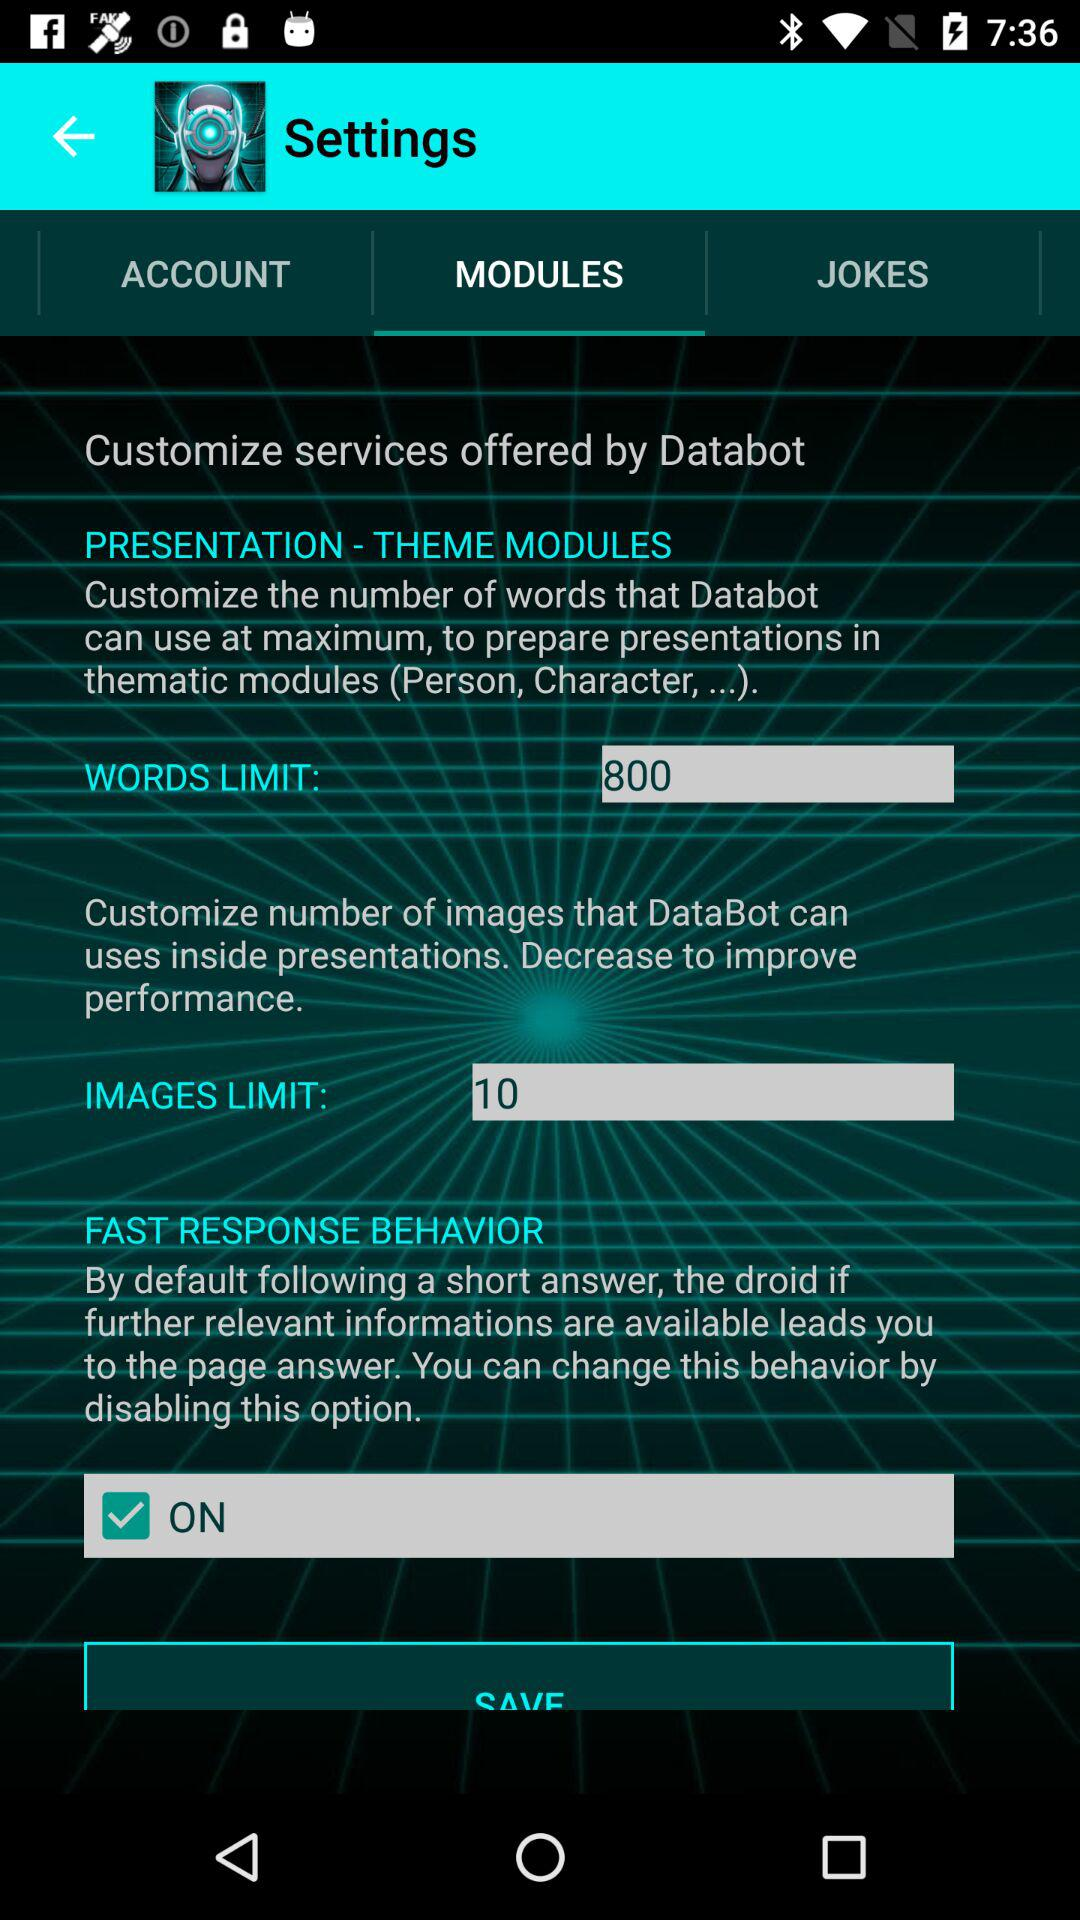What is the status of "Fast Response Behavior"? The status is "on". 